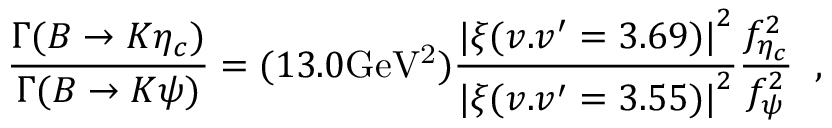Convert formula to latex. <formula><loc_0><loc_0><loc_500><loc_500>\frac { \Gamma ( B \rightarrow K \eta _ { c } ) } { \Gamma ( B \rightarrow K \psi ) } = ( 1 3 . 0 G e V ^ { 2 } ) \frac { { | \xi ( v . v ^ { \prime } = 3 . 6 9 ) | } ^ { 2 } } { { | \xi ( v . v ^ { \prime } = 3 . 5 5 ) | } ^ { 2 } } \frac { f _ { \eta _ { c } } ^ { 2 } } { f _ { \psi } ^ { 2 } } \, ,</formula> 